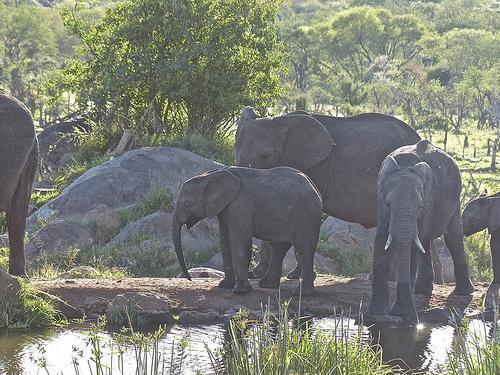How many elephants are there?
Give a very brief answer. 5. 